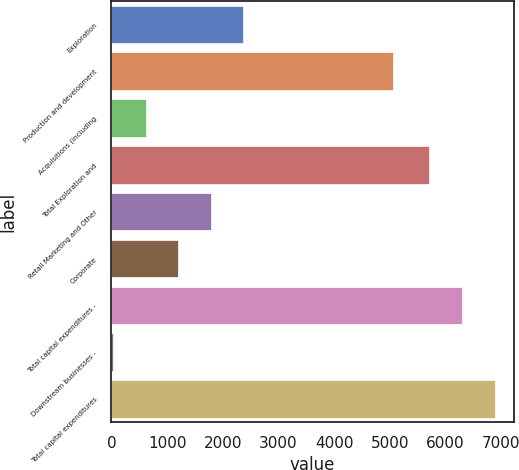<chart> <loc_0><loc_0><loc_500><loc_500><bar_chart><fcel>Exploration<fcel>Production and development<fcel>Acquisitions (including<fcel>Total Exploration and<fcel>Retail Marketing and Other<fcel>Corporate<fcel>Total capital expenditures -<fcel>Downstream businesses -<fcel>Total capital expenditures<nl><fcel>2369<fcel>5051<fcel>617<fcel>5709<fcel>1785<fcel>1201<fcel>6293<fcel>33<fcel>6877<nl></chart> 